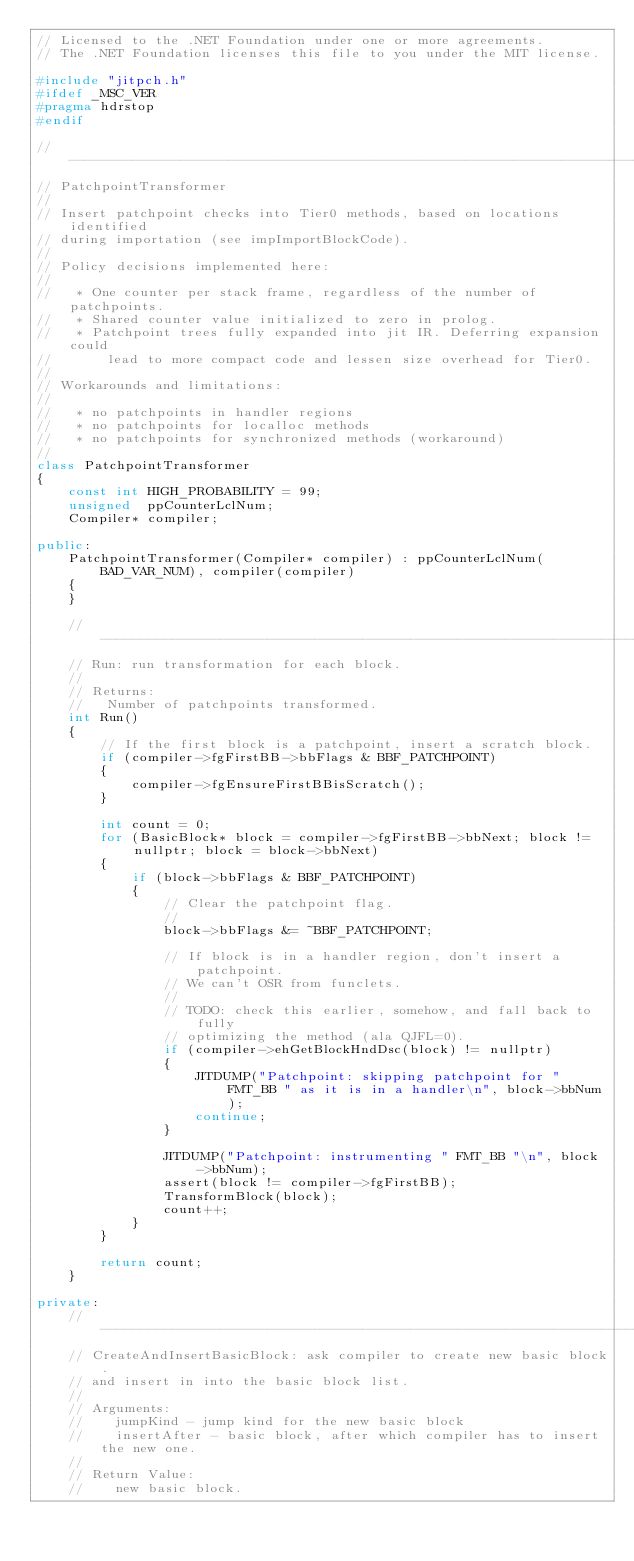<code> <loc_0><loc_0><loc_500><loc_500><_C++_>// Licensed to the .NET Foundation under one or more agreements.
// The .NET Foundation licenses this file to you under the MIT license.

#include "jitpch.h"
#ifdef _MSC_VER
#pragma hdrstop
#endif

//------------------------------------------------------------------------
// PatchpointTransformer
//
// Insert patchpoint checks into Tier0 methods, based on locations identified
// during importation (see impImportBlockCode).
//
// Policy decisions implemented here:
//
//   * One counter per stack frame, regardless of the number of patchpoints.
//   * Shared counter value initialized to zero in prolog.
//   * Patchpoint trees fully expanded into jit IR. Deferring expansion could
//       lead to more compact code and lessen size overhead for Tier0.
//
// Workarounds and limitations:
//
//   * no patchpoints in handler regions
//   * no patchpoints for localloc methods
//   * no patchpoints for synchronized methods (workaround)
//
class PatchpointTransformer
{
    const int HIGH_PROBABILITY = 99;
    unsigned  ppCounterLclNum;
    Compiler* compiler;

public:
    PatchpointTransformer(Compiler* compiler) : ppCounterLclNum(BAD_VAR_NUM), compiler(compiler)
    {
    }

    //------------------------------------------------------------------------
    // Run: run transformation for each block.
    //
    // Returns:
    //   Number of patchpoints transformed.
    int Run()
    {
        // If the first block is a patchpoint, insert a scratch block.
        if (compiler->fgFirstBB->bbFlags & BBF_PATCHPOINT)
        {
            compiler->fgEnsureFirstBBisScratch();
        }

        int count = 0;
        for (BasicBlock* block = compiler->fgFirstBB->bbNext; block != nullptr; block = block->bbNext)
        {
            if (block->bbFlags & BBF_PATCHPOINT)
            {
                // Clear the patchpoint flag.
                //
                block->bbFlags &= ~BBF_PATCHPOINT;

                // If block is in a handler region, don't insert a patchpoint.
                // We can't OSR from funclets.
                //
                // TODO: check this earlier, somehow, and fall back to fully
                // optimizing the method (ala QJFL=0).
                if (compiler->ehGetBlockHndDsc(block) != nullptr)
                {
                    JITDUMP("Patchpoint: skipping patchpoint for " FMT_BB " as it is in a handler\n", block->bbNum);
                    continue;
                }

                JITDUMP("Patchpoint: instrumenting " FMT_BB "\n", block->bbNum);
                assert(block != compiler->fgFirstBB);
                TransformBlock(block);
                count++;
            }
        }

        return count;
    }

private:
    //------------------------------------------------------------------------
    // CreateAndInsertBasicBlock: ask compiler to create new basic block.
    // and insert in into the basic block list.
    //
    // Arguments:
    //    jumpKind - jump kind for the new basic block
    //    insertAfter - basic block, after which compiler has to insert the new one.
    //
    // Return Value:
    //    new basic block.</code> 